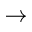<formula> <loc_0><loc_0><loc_500><loc_500>\rightarrow</formula> 